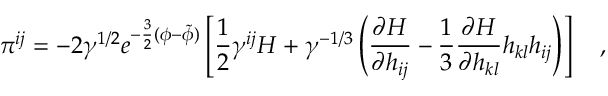<formula> <loc_0><loc_0><loc_500><loc_500>\pi ^ { i j } = - 2 \gamma ^ { 1 / 2 } e ^ { - \frac { 3 } { 2 } ( \phi - \tilde { \phi } ) } \left [ \frac { 1 } { 2 } \gamma ^ { i j } H + \gamma ^ { - 1 / 3 } \left ( \frac { \partial H } { \partial h _ { i j } } - \frac { 1 } { 3 } \frac { \partial H } { \partial h _ { k l } } h _ { k l } h _ { i j } \right ) \right ] ,</formula> 